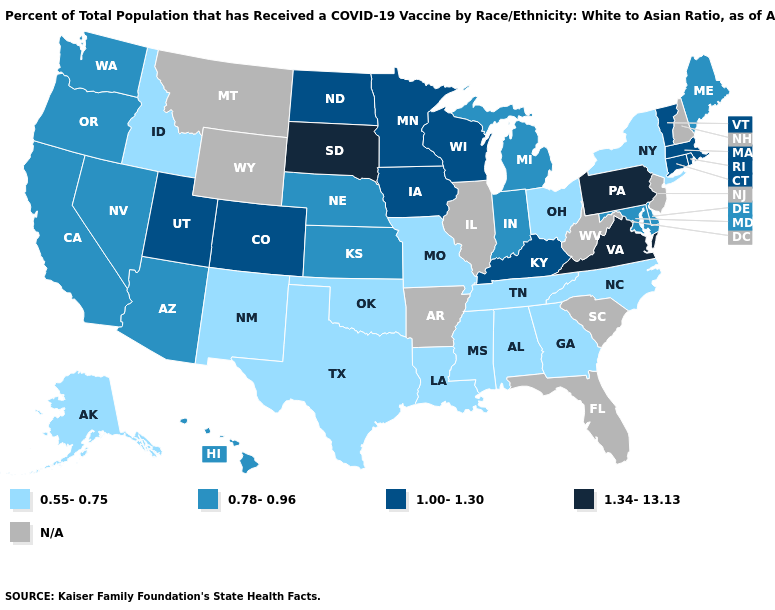What is the highest value in the USA?
Give a very brief answer. 1.34-13.13. Does Colorado have the highest value in the West?
Write a very short answer. Yes. What is the value of Colorado?
Quick response, please. 1.00-1.30. Does Alabama have the highest value in the South?
Keep it brief. No. What is the highest value in the USA?
Short answer required. 1.34-13.13. Which states hav the highest value in the MidWest?
Short answer required. South Dakota. Which states have the lowest value in the USA?
Concise answer only. Alabama, Alaska, Georgia, Idaho, Louisiana, Mississippi, Missouri, New Mexico, New York, North Carolina, Ohio, Oklahoma, Tennessee, Texas. Name the states that have a value in the range 1.00-1.30?
Keep it brief. Colorado, Connecticut, Iowa, Kentucky, Massachusetts, Minnesota, North Dakota, Rhode Island, Utah, Vermont, Wisconsin. Name the states that have a value in the range 0.55-0.75?
Give a very brief answer. Alabama, Alaska, Georgia, Idaho, Louisiana, Mississippi, Missouri, New Mexico, New York, North Carolina, Ohio, Oklahoma, Tennessee, Texas. Does the map have missing data?
Answer briefly. Yes. How many symbols are there in the legend?
Give a very brief answer. 5. Name the states that have a value in the range N/A?
Concise answer only. Arkansas, Florida, Illinois, Montana, New Hampshire, New Jersey, South Carolina, West Virginia, Wyoming. What is the value of Iowa?
Quick response, please. 1.00-1.30. 